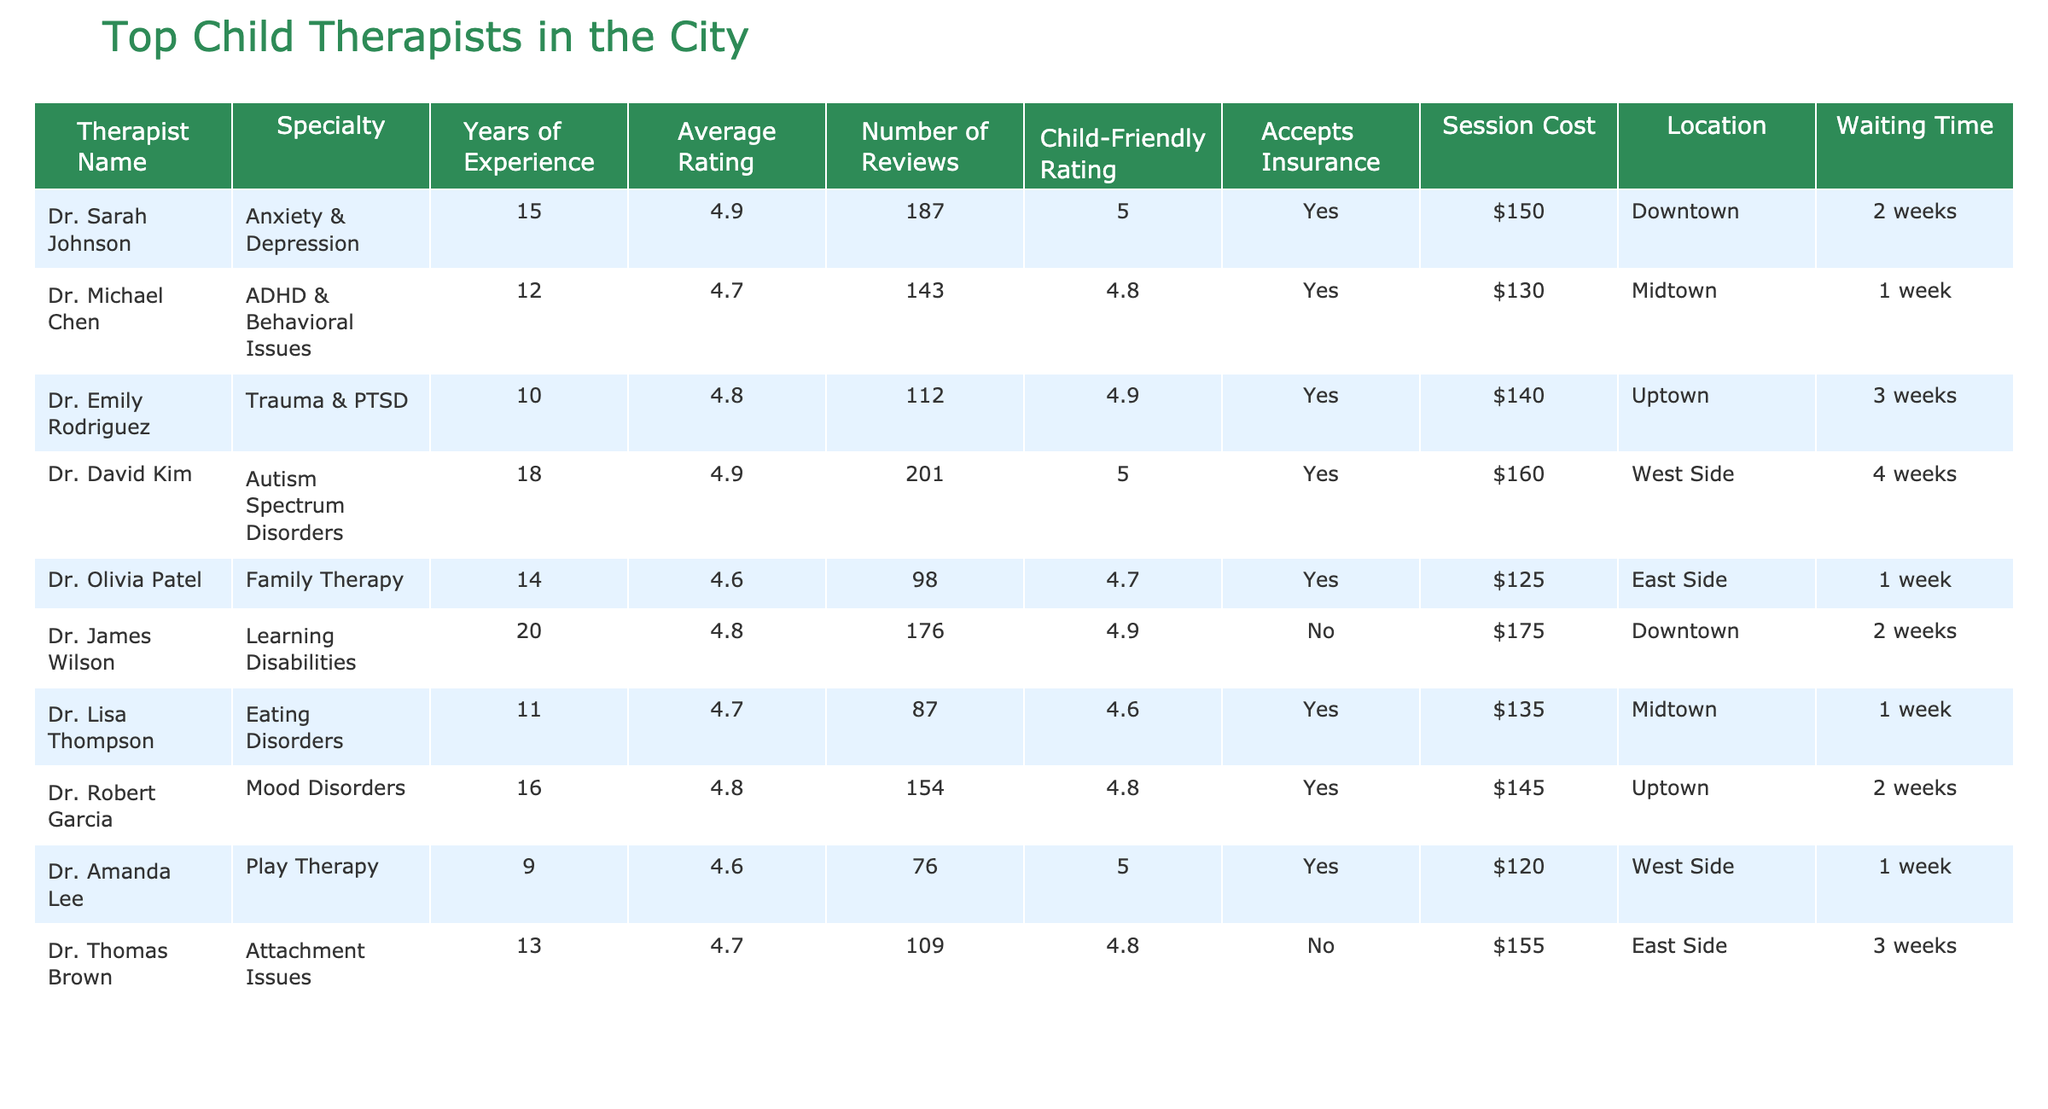What is the average rating of the therapists listed? To find the average rating, we sum the ratings of all therapists: (4.9 + 4.7 + 4.8 + 4.9 + 4.6 + 4.8 + 4.7 + 4.7 + 4.6 + 4.8) = 48.5. There are 10 therapists, so the average rating is 48.5 / 10 = 4.85.
Answer: 4.85 Which therapist has the highest average rating? By examining the average ratings, Dr. Sarah Johnson has the highest rating at 4.9.
Answer: Dr. Sarah Johnson How many therapists accept insurance? Counting the "Yes" responses under the "Accepts Insurance" column reveals that 8 out of 10 therapists accept insurance.
Answer: 8 What is the total session cost for the therapists listed? Adding the session costs ($150 + $130 + $140 + $160 + $125 + $175 + $135 + $145 + $120 + $155) gives us a total of $1,485.
Answer: $1,485 How long is the maximum waiting time among the therapists? Looking at the "Waiting Time" column, the longest waiting time is 4 weeks, associated with Dr. David Kim.
Answer: 4 weeks Is Dr. James Wilson child-friendly? The child-friendly rating for Dr. James Wilson is 4.9, so he is considered child-friendly.
Answer: Yes Which therapist specializes in Trauma & PTSD? The table shows that Dr. Emily Rodriguez specializes in Trauma & PTSD.
Answer: Dr. Emily Rodriguez What is the average child-friendly rating among all therapists? The child-friendly ratings are (5 + 4.8 + 4.9 + 5 + 4.7 + 4.9 + 4.6 + 5 + 4.8 + 4.8) = 49. The average is 49 / 10 = 4.9.
Answer: 4.9 How does the session cost of Dr. Amanda Lee compare to the therapist with the highest cost? Dr. Amanda Lee charges $120, while the highest cost is $175 for Dr. James Wilson. The difference is $175 - $120 = $55.
Answer: $55 Which location has the most therapists listed? Examining the locations, Downtown and Midtown each have 2 therapists, which is the highest count.
Answer: Downtown and Midtown 